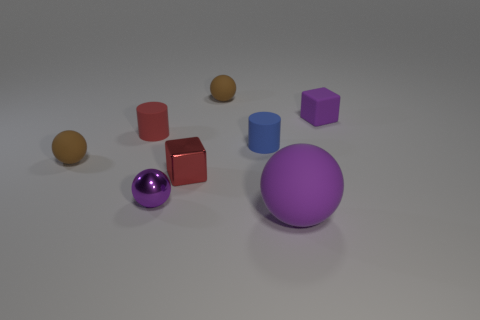Add 1 cylinders. How many objects exist? 9 Subtract all blocks. How many objects are left? 6 Add 7 tiny purple objects. How many tiny purple objects are left? 9 Add 4 tiny blue metal blocks. How many tiny blue metal blocks exist? 4 Subtract 1 purple balls. How many objects are left? 7 Subtract all big rubber spheres. Subtract all tiny shiny things. How many objects are left? 5 